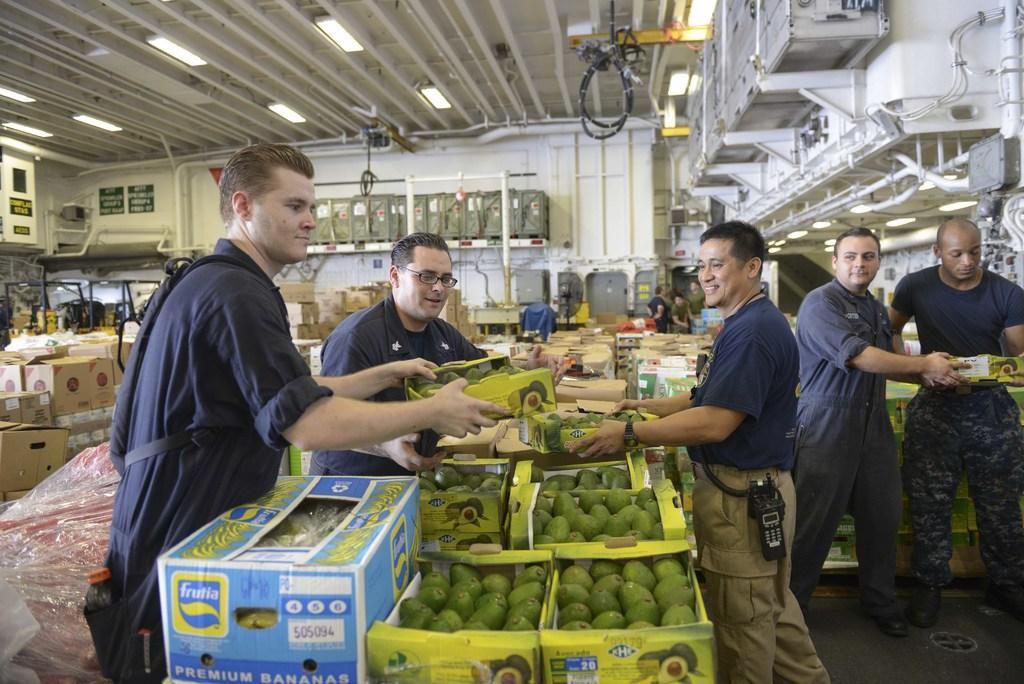Who or what is present in the image? There are people in the image. What objects can be seen alongside the people? There are boxes in the image. What is inside the boxes? The boxes contain mangoes. What can be seen providing illumination in the image? There are lights visible in the image. Is there a river flowing through the scene in the image? No, there is no river present in the image. What type of meal is being prepared or served in the image? There is no meal preparation or serving depicted in the image; it primarily features people and boxes containing mangoes. 